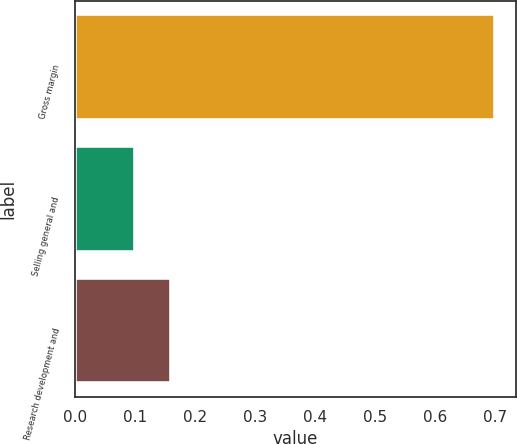Convert chart to OTSL. <chart><loc_0><loc_0><loc_500><loc_500><bar_chart><fcel>Gross margin<fcel>Selling general and<fcel>Research development and<nl><fcel>0.7<fcel>0.1<fcel>0.16<nl></chart> 